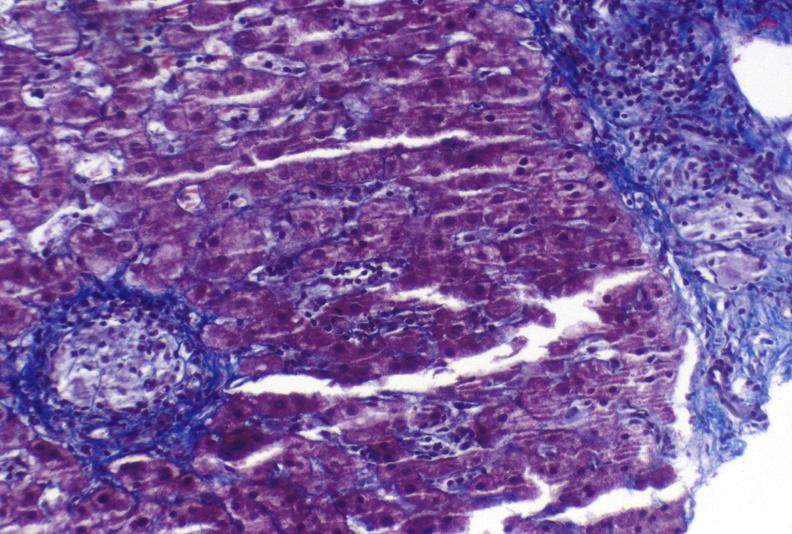s hepatobiliary present?
Answer the question using a single word or phrase. Yes 